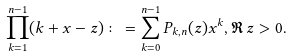<formula> <loc_0><loc_0><loc_500><loc_500>\prod _ { k = 1 } ^ { n - 1 } ( k + x - z ) \colon = \sum _ { k = 0 } ^ { n - 1 } P _ { k , n } ( z ) x ^ { k } , \Re \, z > 0 .</formula> 